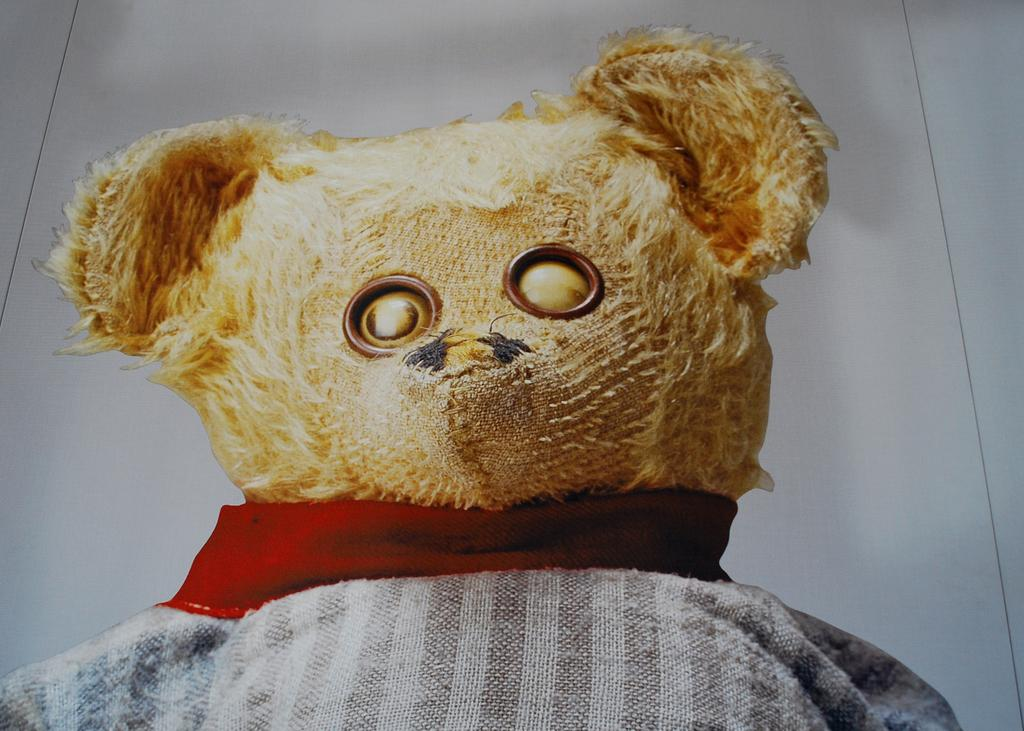What is on the floor in the image? There is a teddy bear on the floor in the image. What type of cracker is the teddy bear holding in the image? There is no cracker present in the image; the teddy bear is not holding anything. 